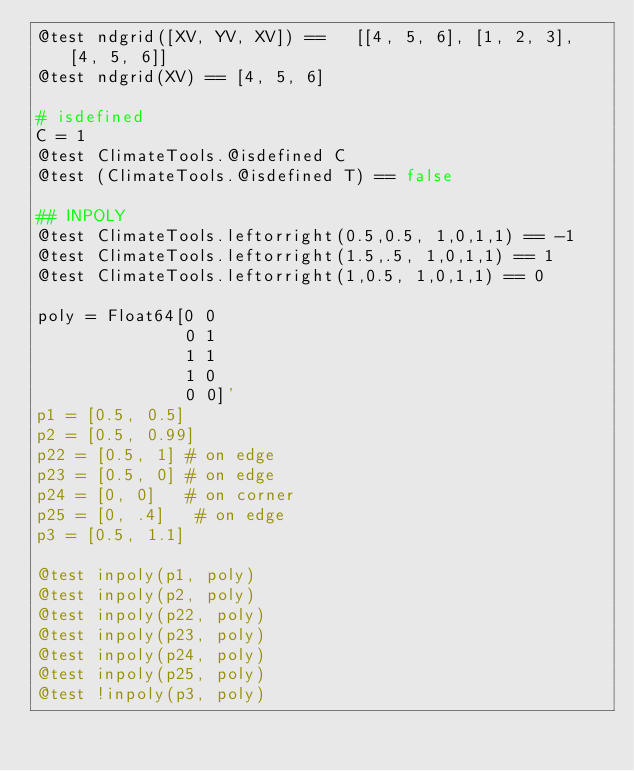<code> <loc_0><loc_0><loc_500><loc_500><_Julia_>@test ndgrid([XV, YV, XV]) ==   [[4, 5, 6], [1, 2, 3], [4, 5, 6]]
@test ndgrid(XV) == [4, 5, 6]

# isdefined
C = 1
@test ClimateTools.@isdefined C
@test (ClimateTools.@isdefined T) == false

## INPOLY
@test ClimateTools.leftorright(0.5,0.5, 1,0,1,1) == -1
@test ClimateTools.leftorright(1.5,.5, 1,0,1,1) == 1
@test ClimateTools.leftorright(1,0.5, 1,0,1,1) == 0

poly = Float64[0 0
               0 1
               1 1
               1 0
               0 0]'
p1 = [0.5, 0.5]
p2 = [0.5, 0.99]
p22 = [0.5, 1] # on edge
p23 = [0.5, 0] # on edge
p24 = [0, 0]   # on corner
p25 = [0, .4]   # on edge
p3 = [0.5, 1.1]

@test inpoly(p1, poly)
@test inpoly(p2, poly)
@test inpoly(p22, poly)
@test inpoly(p23, poly)
@test inpoly(p24, poly)
@test inpoly(p25, poly)
@test !inpoly(p3, poly)
</code> 